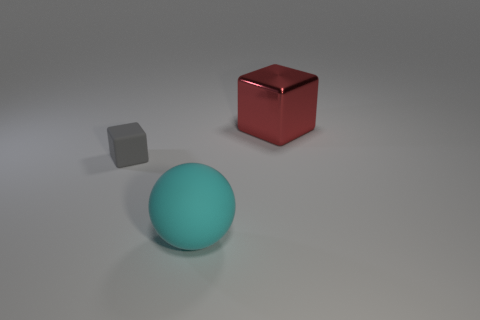Add 2 shiny things. How many objects exist? 5 Subtract all balls. How many objects are left? 2 Subtract all blue cubes. Subtract all tiny gray objects. How many objects are left? 2 Add 1 gray things. How many gray things are left? 2 Add 3 small brown cylinders. How many small brown cylinders exist? 3 Subtract 0 gray spheres. How many objects are left? 3 